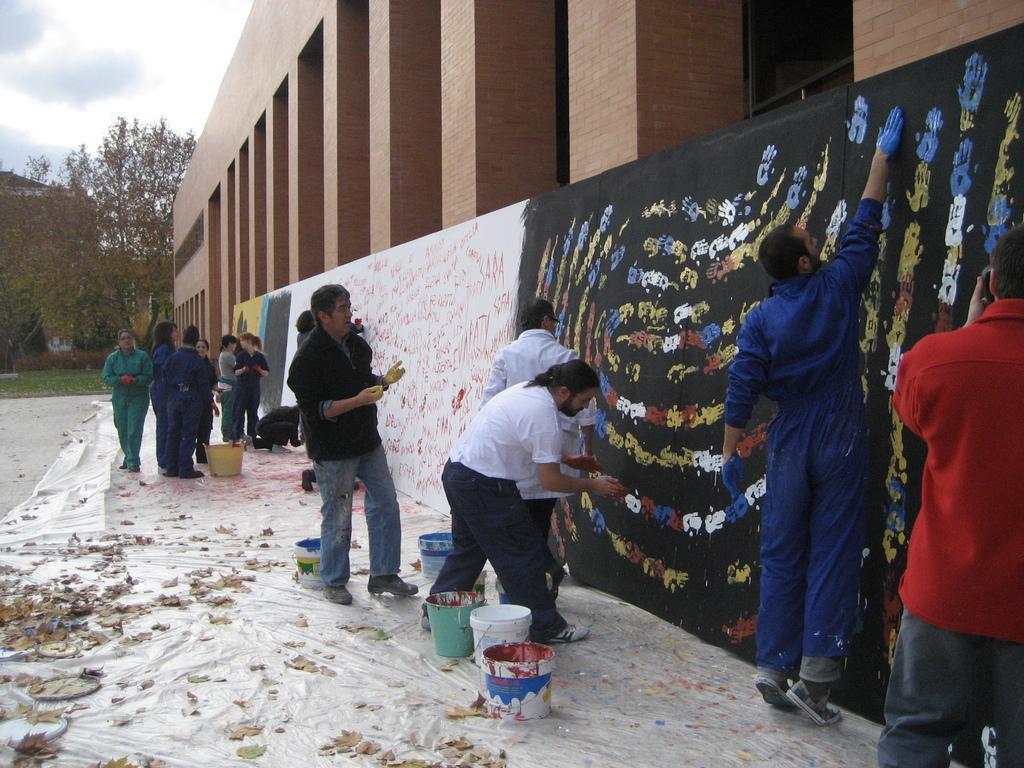Describe this image in one or two sentences. As we can see in the image there are buildings, trees, buckets, leaves, few people and at the top there is sky. 